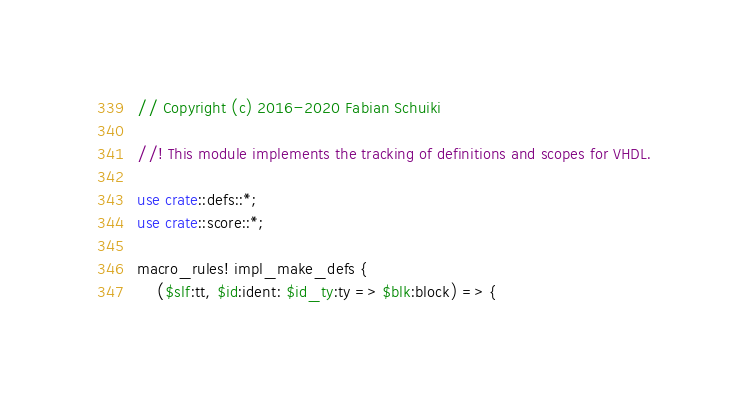<code> <loc_0><loc_0><loc_500><loc_500><_Rust_>// Copyright (c) 2016-2020 Fabian Schuiki

//! This module implements the tracking of definitions and scopes for VHDL.

use crate::defs::*;
use crate::score::*;

macro_rules! impl_make_defs {
    ($slf:tt, $id:ident: $id_ty:ty => $blk:block) => {</code> 